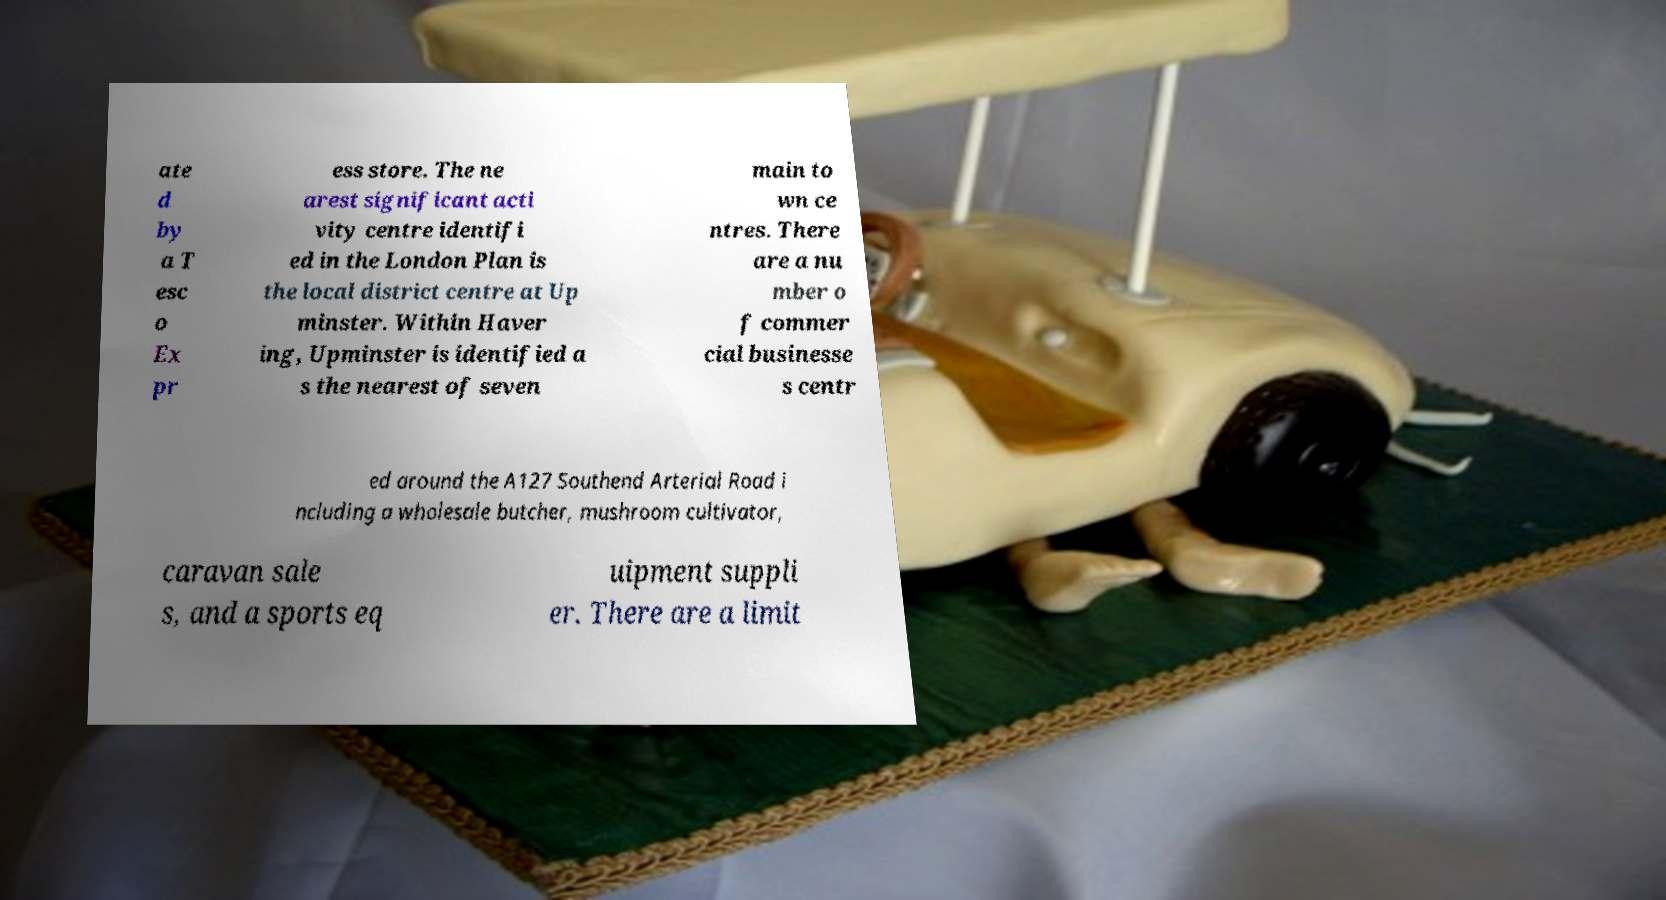What messages or text are displayed in this image? I need them in a readable, typed format. ate d by a T esc o Ex pr ess store. The ne arest significant acti vity centre identifi ed in the London Plan is the local district centre at Up minster. Within Haver ing, Upminster is identified a s the nearest of seven main to wn ce ntres. There are a nu mber o f commer cial businesse s centr ed around the A127 Southend Arterial Road i ncluding a wholesale butcher, mushroom cultivator, caravan sale s, and a sports eq uipment suppli er. There are a limit 